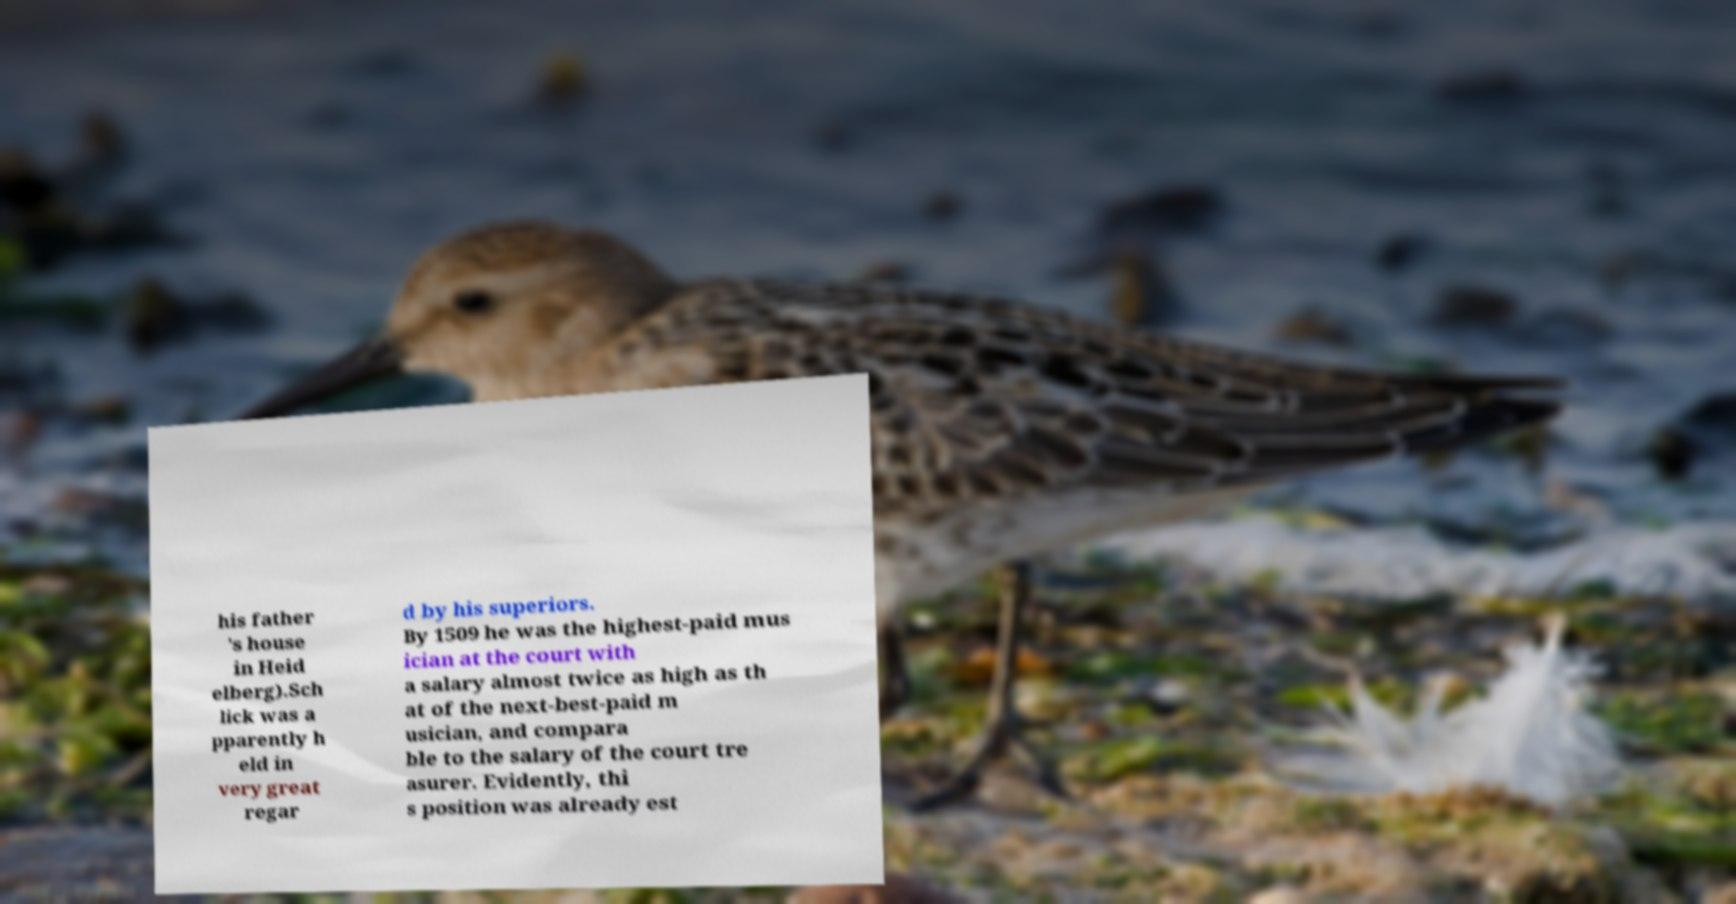Please identify and transcribe the text found in this image. his father 's house in Heid elberg).Sch lick was a pparently h eld in very great regar d by his superiors. By 1509 he was the highest-paid mus ician at the court with a salary almost twice as high as th at of the next-best-paid m usician, and compara ble to the salary of the court tre asurer. Evidently, thi s position was already est 